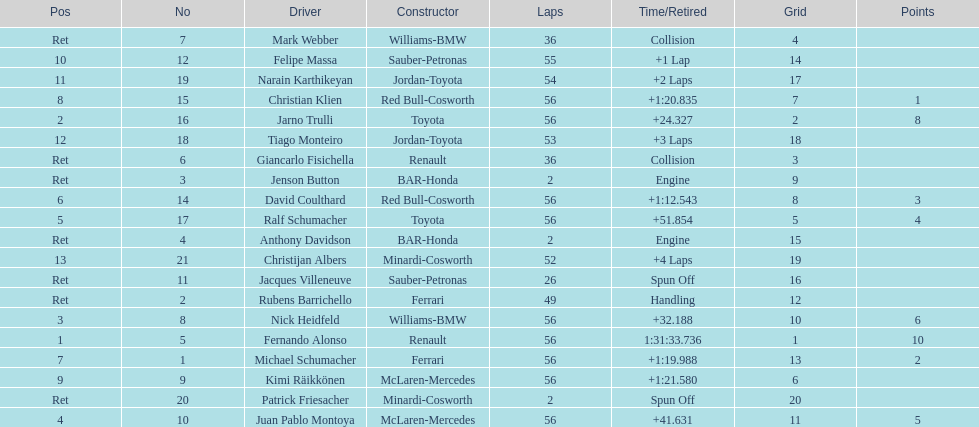Can you give me this table as a dict? {'header': ['Pos', 'No', 'Driver', 'Constructor', 'Laps', 'Time/Retired', 'Grid', 'Points'], 'rows': [['Ret', '7', 'Mark Webber', 'Williams-BMW', '36', 'Collision', '4', ''], ['10', '12', 'Felipe Massa', 'Sauber-Petronas', '55', '+1 Lap', '14', ''], ['11', '19', 'Narain Karthikeyan', 'Jordan-Toyota', '54', '+2 Laps', '17', ''], ['8', '15', 'Christian Klien', 'Red Bull-Cosworth', '56', '+1:20.835', '7', '1'], ['2', '16', 'Jarno Trulli', 'Toyota', '56', '+24.327', '2', '8'], ['12', '18', 'Tiago Monteiro', 'Jordan-Toyota', '53', '+3 Laps', '18', ''], ['Ret', '6', 'Giancarlo Fisichella', 'Renault', '36', 'Collision', '3', ''], ['Ret', '3', 'Jenson Button', 'BAR-Honda', '2', 'Engine', '9', ''], ['6', '14', 'David Coulthard', 'Red Bull-Cosworth', '56', '+1:12.543', '8', '3'], ['5', '17', 'Ralf Schumacher', 'Toyota', '56', '+51.854', '5', '4'], ['Ret', '4', 'Anthony Davidson', 'BAR-Honda', '2', 'Engine', '15', ''], ['13', '21', 'Christijan Albers', 'Minardi-Cosworth', '52', '+4 Laps', '19', ''], ['Ret', '11', 'Jacques Villeneuve', 'Sauber-Petronas', '26', 'Spun Off', '16', ''], ['Ret', '2', 'Rubens Barrichello', 'Ferrari', '49', 'Handling', '12', ''], ['3', '8', 'Nick Heidfeld', 'Williams-BMW', '56', '+32.188', '10', '6'], ['1', '5', 'Fernando Alonso', 'Renault', '56', '1:31:33.736', '1', '10'], ['7', '1', 'Michael Schumacher', 'Ferrari', '56', '+1:19.988', '13', '2'], ['9', '9', 'Kimi Räikkönen', 'McLaren-Mercedes', '56', '+1:21.580', '6', ''], ['Ret', '20', 'Patrick Friesacher', 'Minardi-Cosworth', '2', 'Spun Off', '20', ''], ['4', '10', 'Juan Pablo Montoya', 'McLaren-Mercedes', '56', '+41.631', '11', '5']]} What were the total number of laps completed by the 1st position winner? 56. 